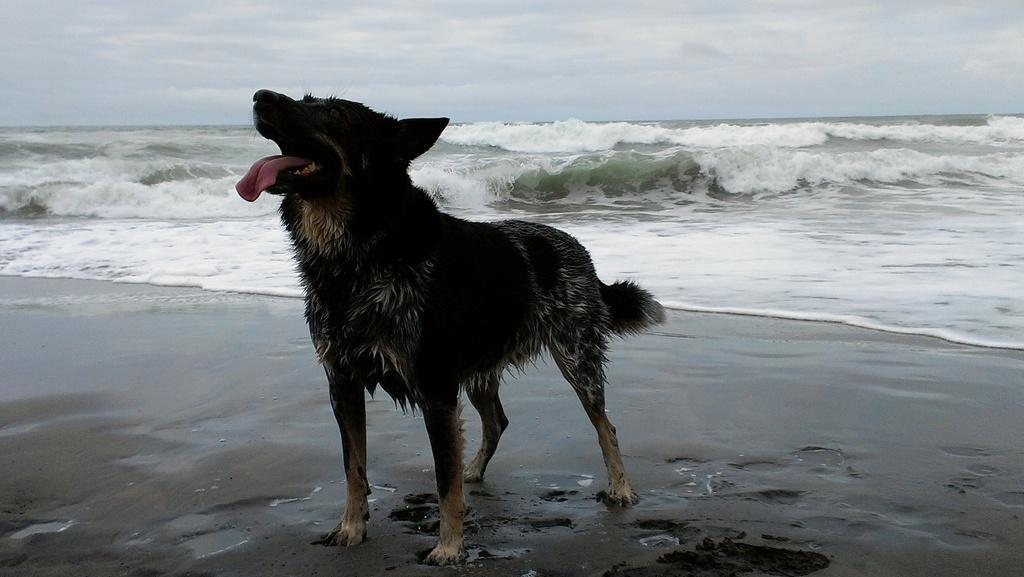Could you give a brief overview of what you see in this image? In the image there is a dog standing on the seashore. Behind the dog there are waves. At the top of the image there is a sky with clouds. 